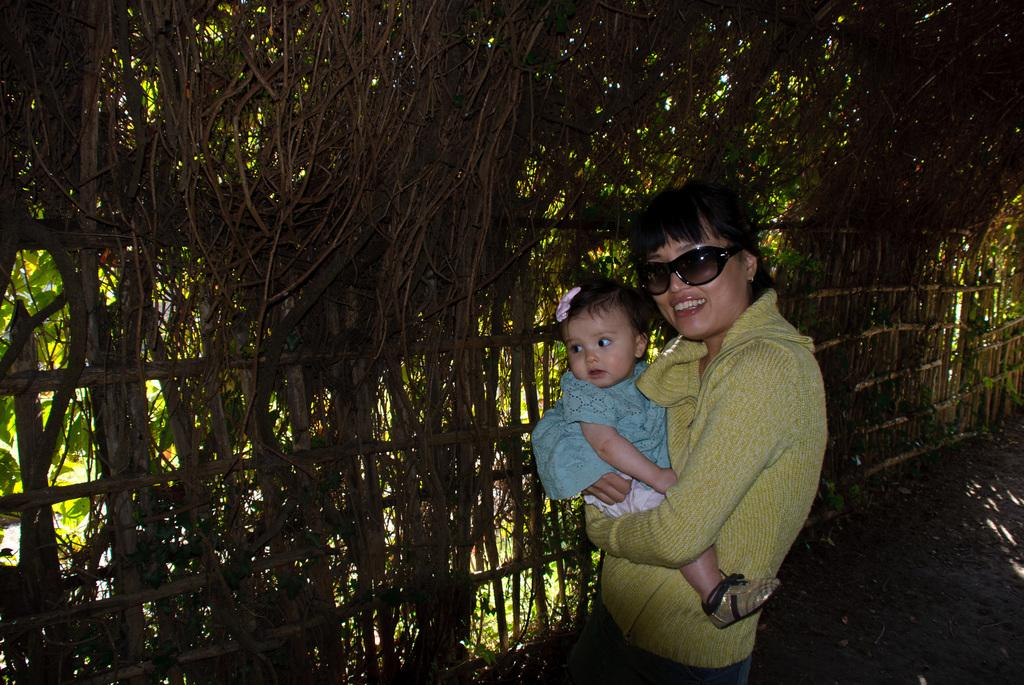What is happening in the image involving the lady and the girl? There is a lady holding a girl in the image. What can be seen in the background of the image? There is a wooden fencing in the background of the image. What natural element is visible in the image? There are roots visible in the image. What type of instrument is being played by the girl in the image? There is no instrument being played in the image; the girl is being held by the lady. 